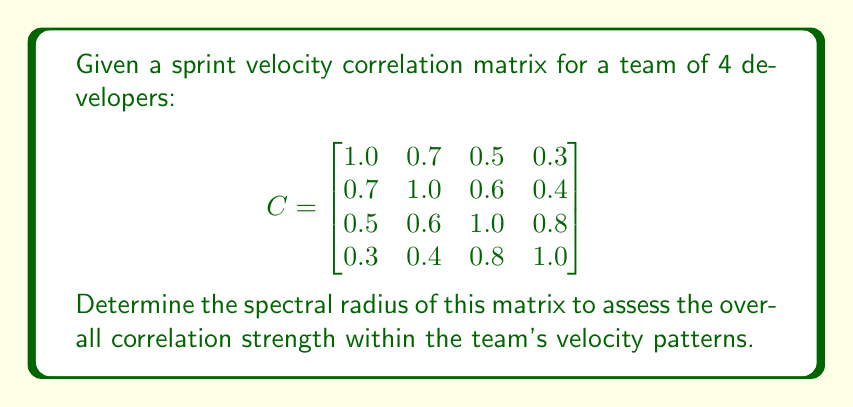Can you solve this math problem? To find the spectral radius of the correlation matrix C, we need to follow these steps:

1. Calculate the eigenvalues of the matrix C.
2. Find the absolute values of these eigenvalues.
3. The spectral radius is the maximum of these absolute values.

Step 1: Calculate the eigenvalues

To find the eigenvalues, we need to solve the characteristic equation:
$$ \det(C - \lambda I) = 0 $$

Expanding this determinant leads to a 4th-degree polynomial equation:
$$ \lambda^4 - 4\lambda^3 + 3.7900\lambda^2 - 1.5160\lambda + 0.2209 = 0 $$

Solving this equation numerically (as exact solutions are complex), we get:

$$ \lambda_1 \approx 2.6934 $$
$$ \lambda_2 \approx 0.8660 $$
$$ \lambda_3 \approx 0.2406 $$
$$ \lambda_4 \approx 0.2000 $$

Step 2: Find absolute values

Since all eigenvalues are already positive, their absolute values are the same.

Step 3: Find the maximum

The maximum of these values is $\lambda_1 \approx 2.6934$.

Therefore, the spectral radius of the correlation matrix C is approximately 2.6934.

In the context of sprint velocity correlations, this relatively high spectral radius (> 1) indicates strong overall correlations within the team's velocity patterns. As a product owner, this suggests that the team's performance is highly interconnected, and changes in one developer's velocity might significantly impact others.
Answer: $2.6934$ 